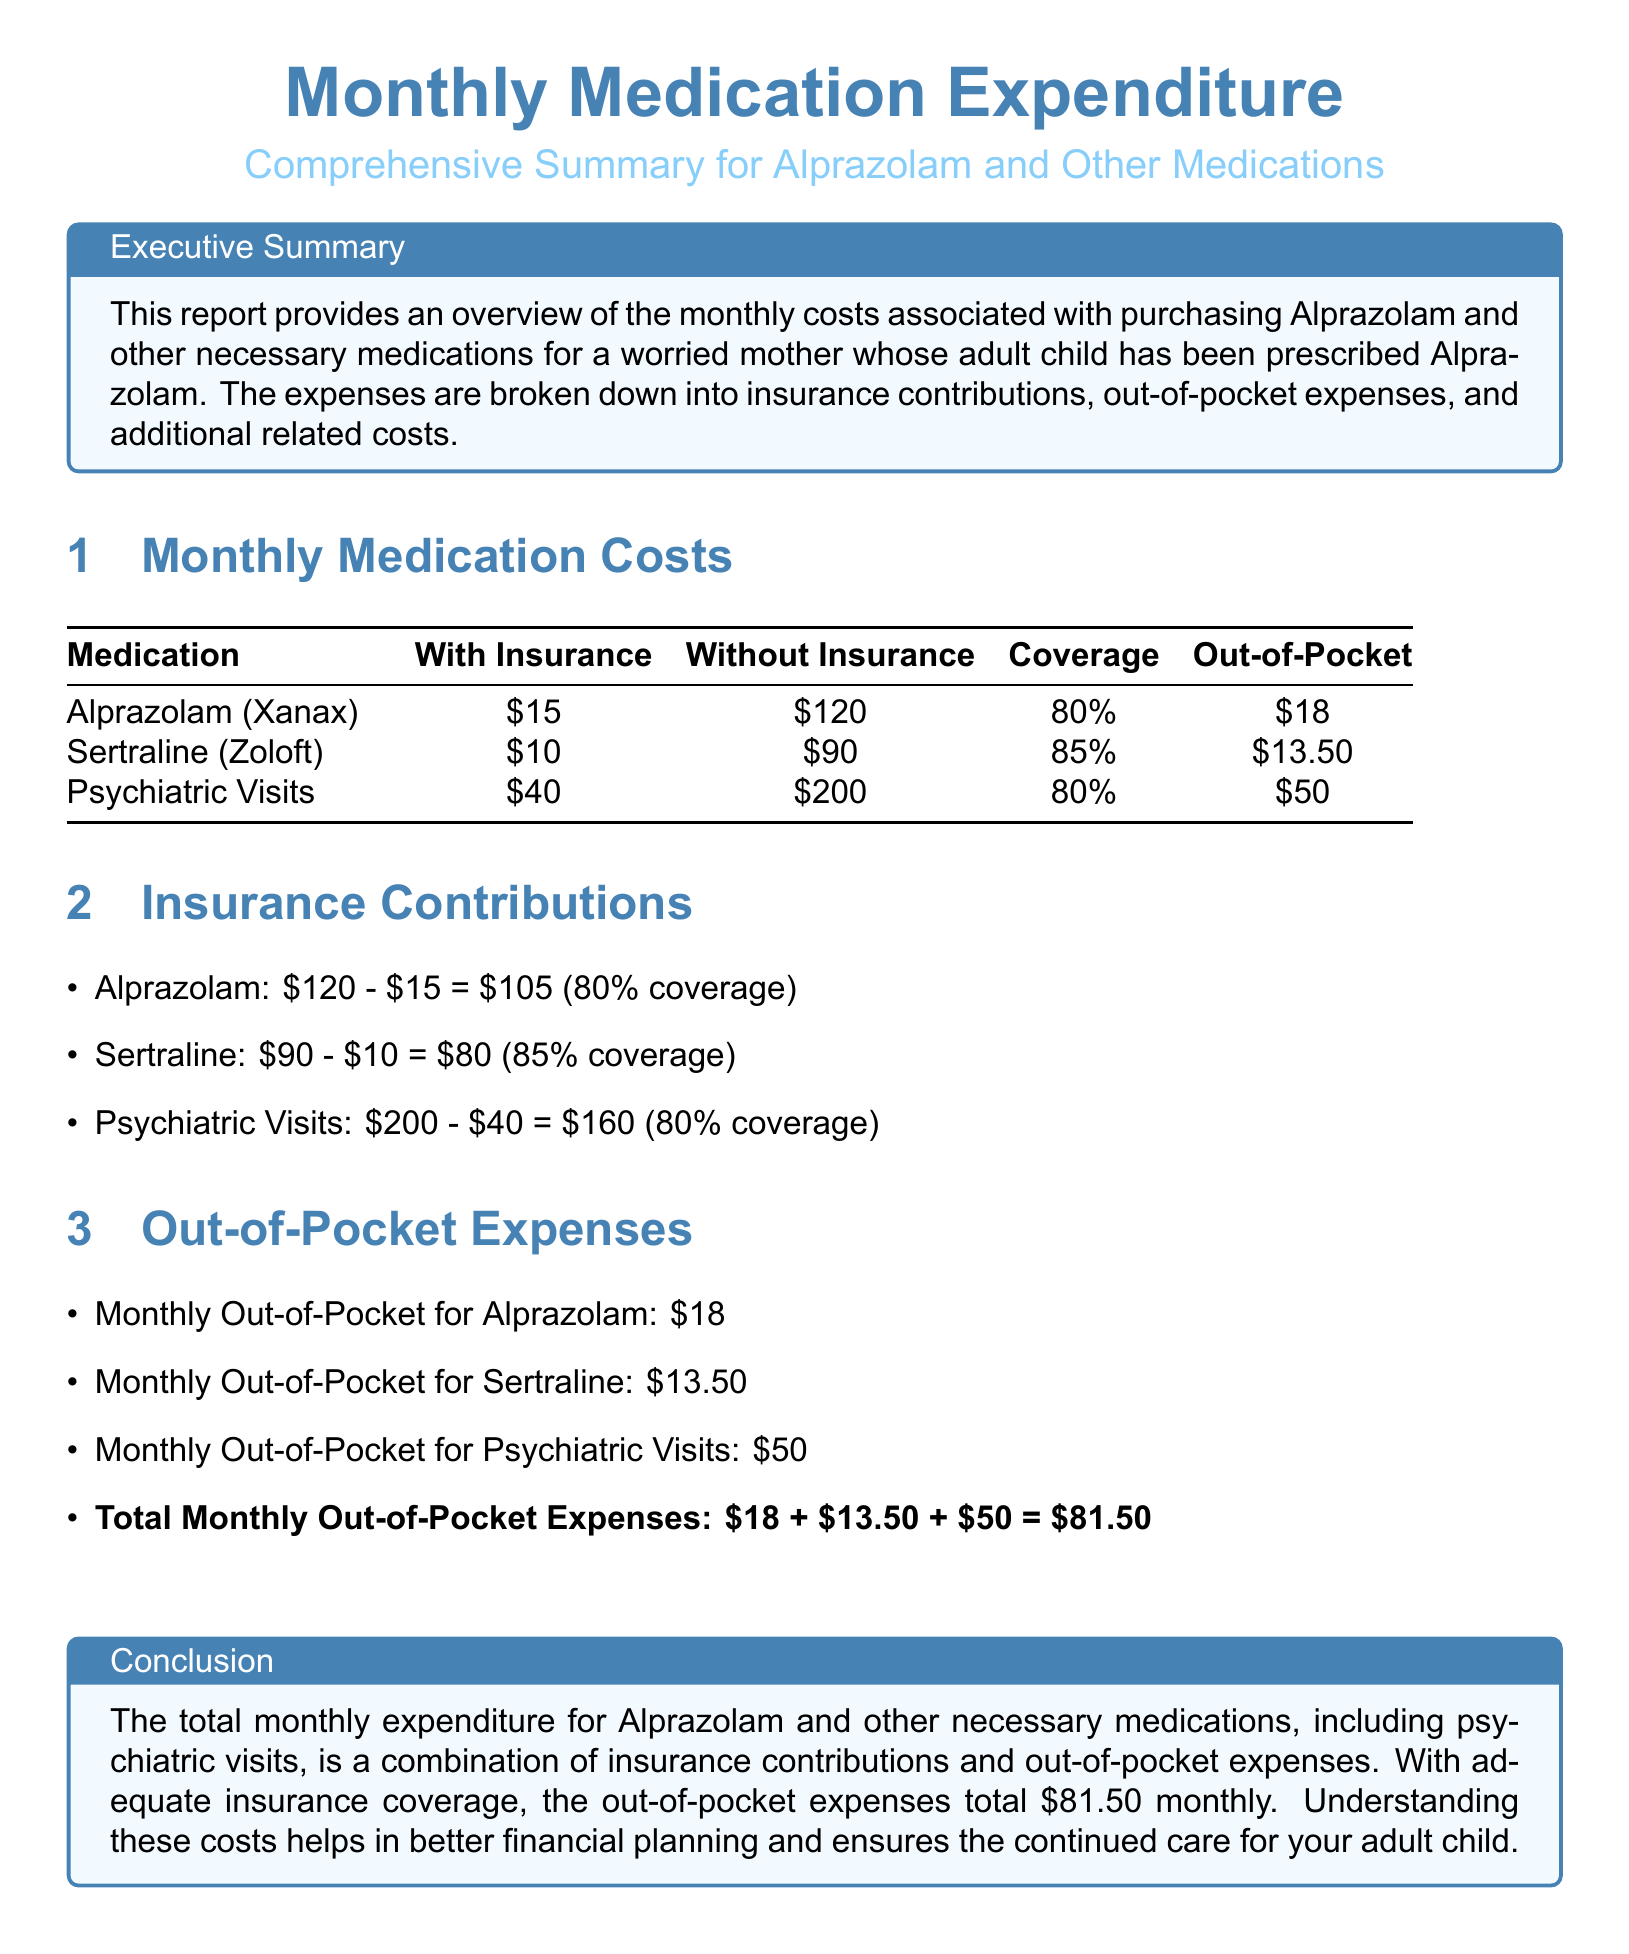What is the total monthly out-of-pocket expense? The total monthly out-of-pocket expenses are calculated as \$18 + \$13.50 + \$50 = \$81.50.
Answer: \$81.50 What is the coverage percentage for Alprazolam? The document states that the coverage percentage for Alprazolam is 80%.
Answer: 80% How much does Sertraline cost without insurance? The document lists the cost of Sertraline without insurance as \$90.
Answer: \$90 What is the insurance contribution for psychiatric visits? The insurance contribution is calculated as \$200 - \$40 = \$160 based on 80% coverage.
Answer: \$160 How much is the monthly out-of-pocket for Alprazolam? The monthly out-of-pocket expense specifically for Alprazolam is mentioned as \$18.
Answer: \$18 What is the coverage for Sertraline? The document specifies the coverage for Sertraline as 85%.
Answer: 85% What is the cost of psychiatric visits with insurance? The cost of psychiatric visits with insurance listed in the document is \$40.
Answer: \$40 What is the highest out-of-pocket expense among the medications? Comparing the out-of-pocket expenses, \$50 for psychiatric visits is the highest.
Answer: \$50 What are the total costs for medications with insurance? The document shows the total costs with insurance as \$15 for Alprazolam, \$10 for Sertraline, and \$40 for psychiatric visits.
Answer: \$15, \$10, \$40 